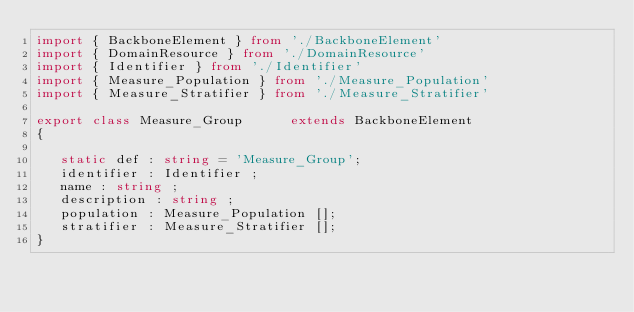Convert code to text. <code><loc_0><loc_0><loc_500><loc_500><_TypeScript_>import { BackboneElement } from './BackboneElement'
import { DomainResource } from './DomainResource'
import { Identifier } from './Identifier'
import { Measure_Population } from './Measure_Population'
import { Measure_Stratifier } from './Measure_Stratifier'

export class Measure_Group      extends BackboneElement
{

   static def : string = 'Measure_Group';
   identifier : Identifier ;
   name : string ;
   description : string ;
   population : Measure_Population [];
   stratifier : Measure_Stratifier [];
}
</code> 